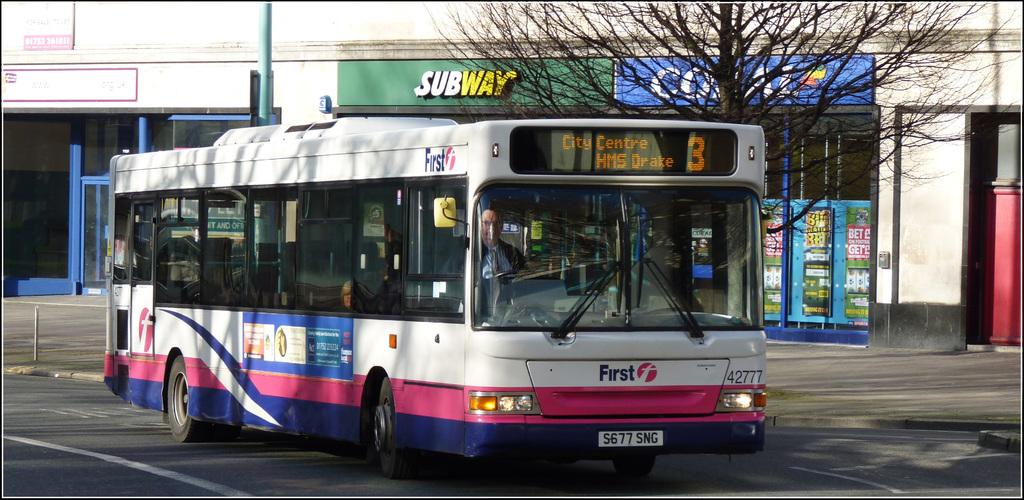<image>
Provide a brief description of the given image. the word First is on the bus on the street 